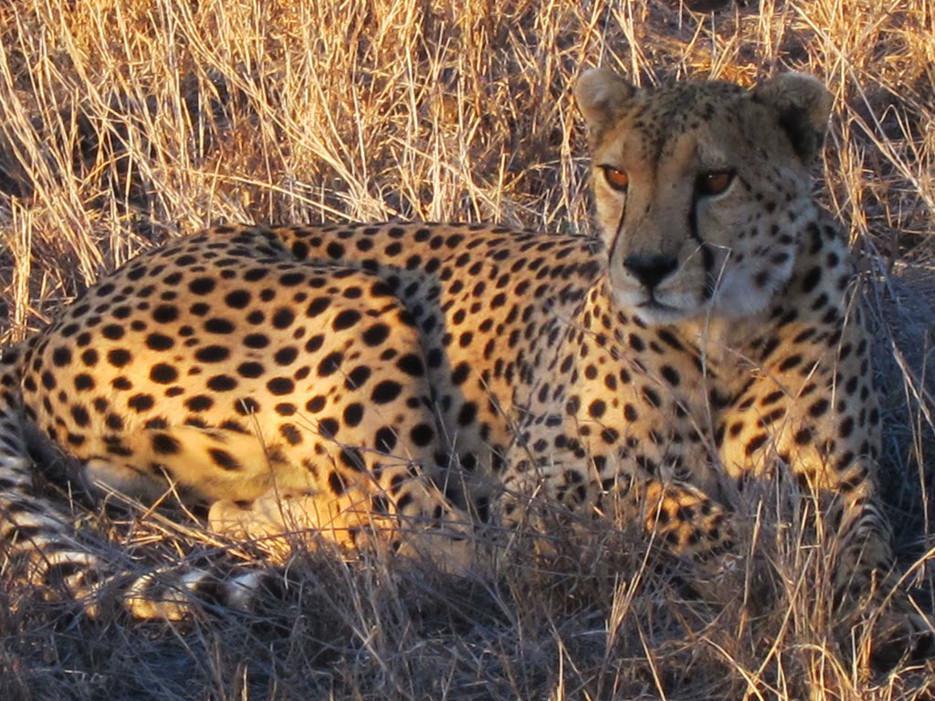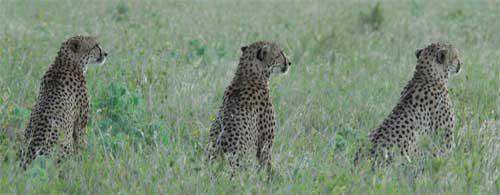The first image is the image on the left, the second image is the image on the right. Assess this claim about the two images: "There is at least two cheetahs in the left image.". Correct or not? Answer yes or no. No. The first image is the image on the left, the second image is the image on the right. Evaluate the accuracy of this statement regarding the images: "One image includes three cheetahs of the same size sitting upright in a row in lookalike poses.". Is it true? Answer yes or no. Yes. 